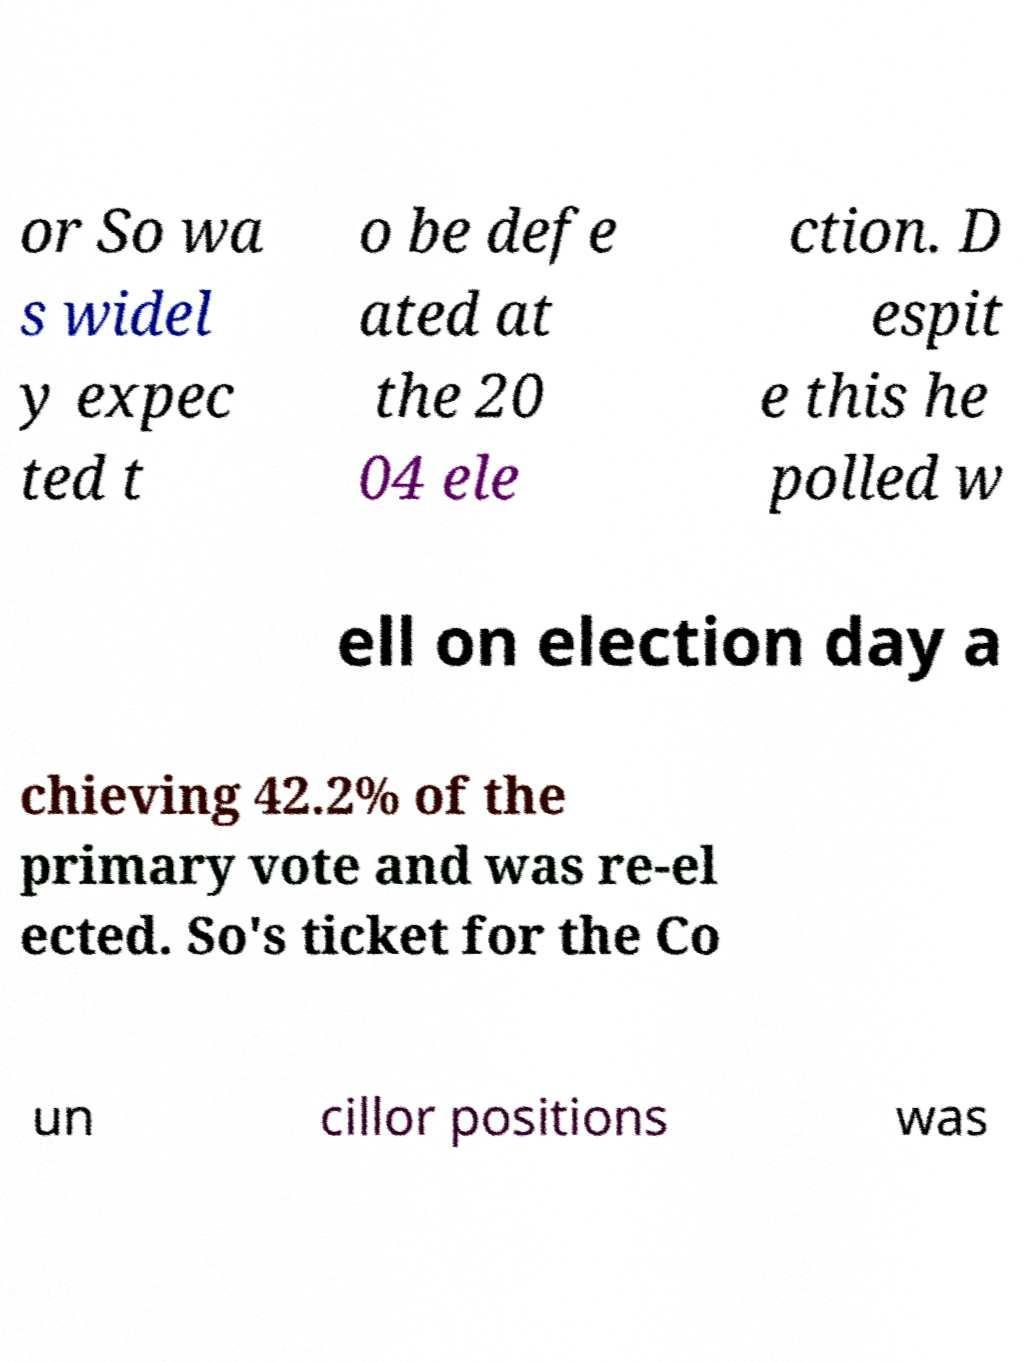Please identify and transcribe the text found in this image. or So wa s widel y expec ted t o be defe ated at the 20 04 ele ction. D espit e this he polled w ell on election day a chieving 42.2% of the primary vote and was re-el ected. So's ticket for the Co un cillor positions was 